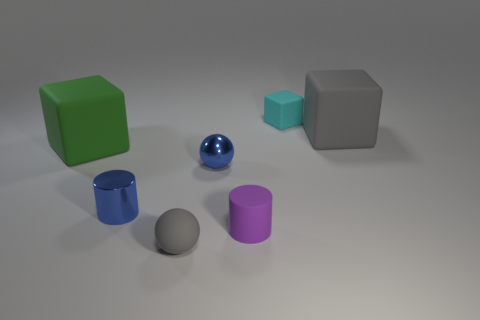There is a block in front of the big gray cube; is it the same color as the large rubber block that is on the right side of the cyan cube?
Your answer should be compact. No. What number of blue things are in front of the gray matte ball?
Keep it short and to the point. 0. What number of matte cubes have the same color as the small matte sphere?
Provide a short and direct response. 1. Do the small object that is behind the gray rubber cube and the big gray cube have the same material?
Provide a succinct answer. Yes. What number of small cylinders are made of the same material as the cyan thing?
Your answer should be compact. 1. Are there more small things that are on the right side of the purple thing than big green matte cubes?
Provide a succinct answer. No. What is the size of the sphere that is the same color as the shiny cylinder?
Offer a terse response. Small. Are there any tiny red things that have the same shape as the green rubber object?
Provide a short and direct response. No. What number of objects are either small purple cylinders or large cyan rubber cylinders?
Provide a short and direct response. 1. There is a gray thing that is to the right of the small thing that is behind the green cube; what number of tiny cyan blocks are in front of it?
Provide a succinct answer. 0. 